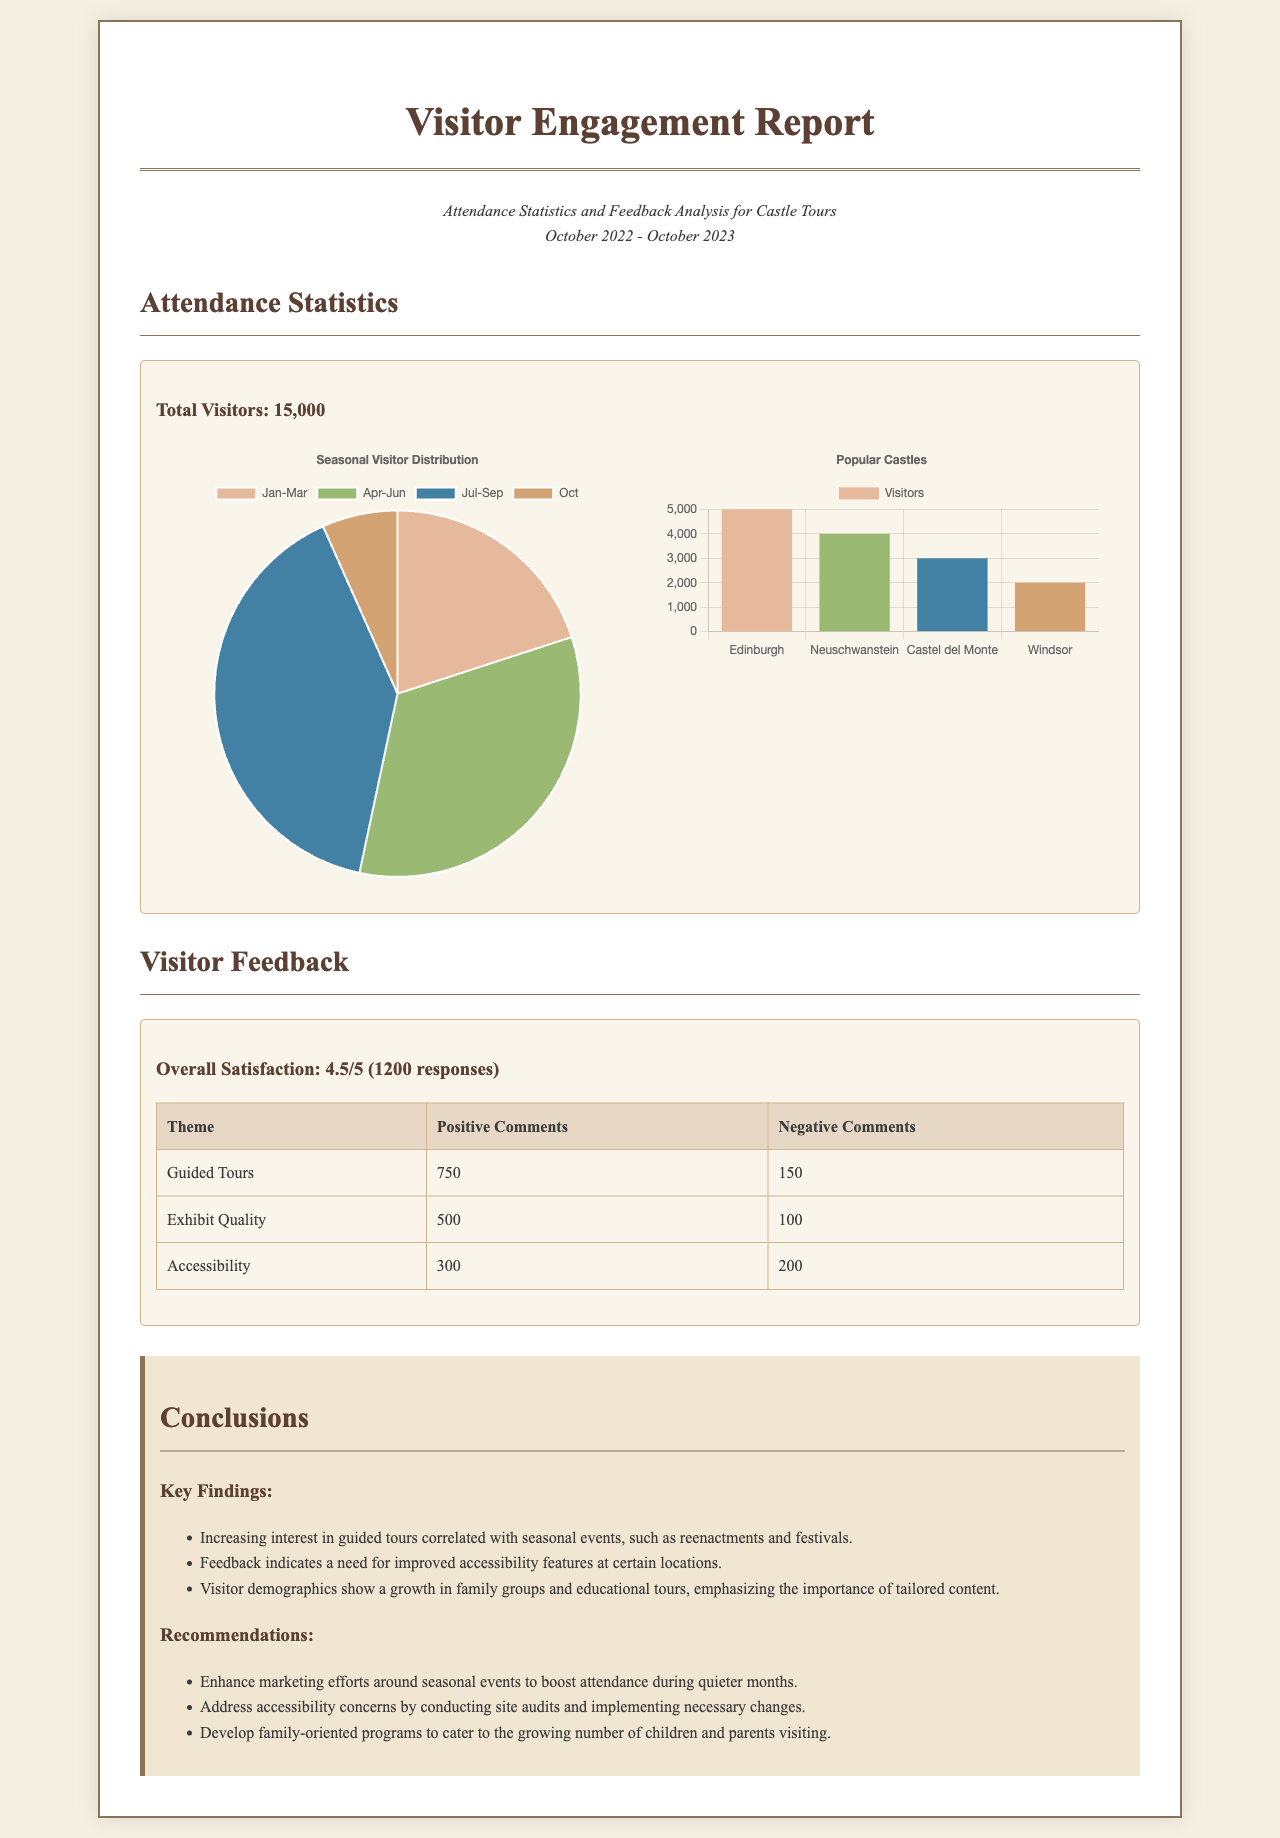What was the total number of visitors? The document states that the total number of visitors was 15,000.
Answer: 15,000 What was the overall satisfaction rating? The report indicates an overall satisfaction rating of 4.5 out of 5 based on 1,200 responses.
Answer: 4.5/5 How many positive comments were there for guided tours? The table lists 750 positive comments for guided tours.
Answer: 750 Which castle had the highest number of visitors? The bar chart shows that Edinburgh castle had the highest number of visitors at 5,000.
Answer: Edinburgh What is a key finding related to visitor demographics? The report notes a growth in family groups and educational tours.
Answer: Family groups What does the seasonal visitor distribution indicate for April to June? The pie chart shows that the period from April to June had 5,000 visitors.
Answer: 5,000 What is a recommendation given in the report regarding accessibility? One of the recommendations is to conduct site audits for accessibility concerns.
Answer: Site audits How many negative comments were received about accessibility? The document states there were 200 negative comments regarding accessibility.
Answer: 200 What month had the least number of visitors? According to the seasonal chart, October had the least number of visitors with 1,000.
Answer: October 